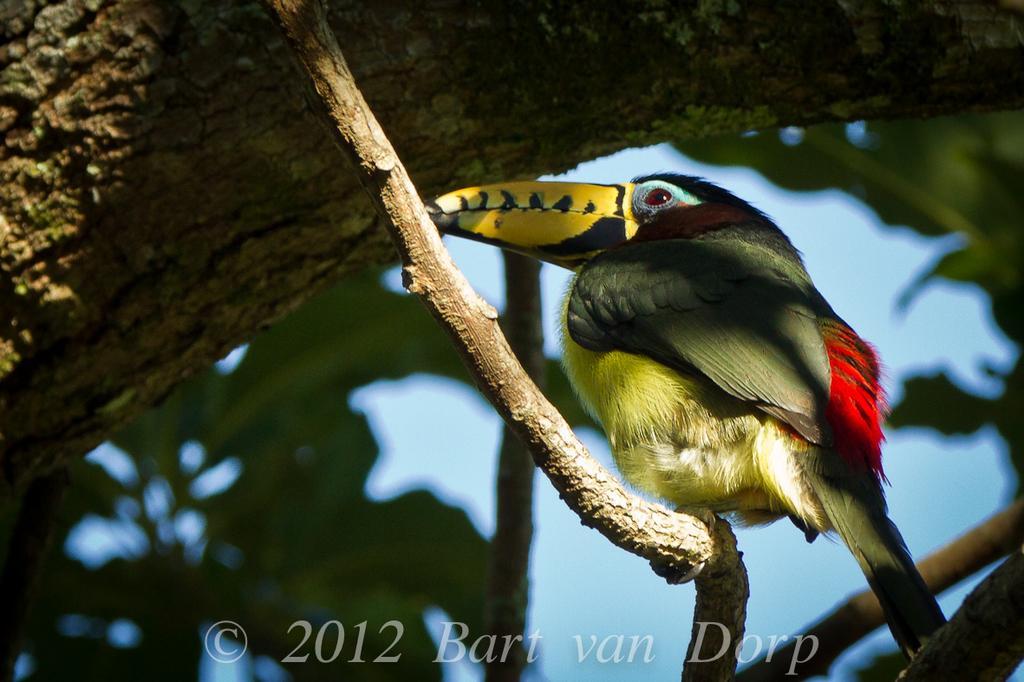How would you summarize this image in a sentence or two? In the center of the image there is a bird on the branch of a tree. In the background there is a sky. 